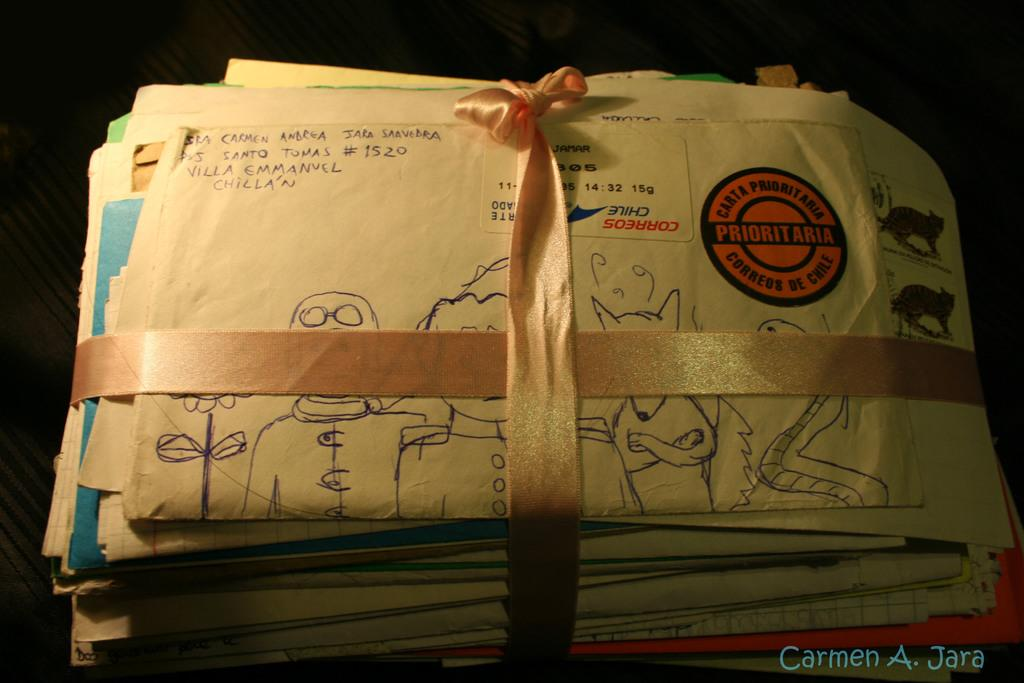<image>
Provide a brief description of the given image. envelopes with a sticker on the top one that says prioritaria 